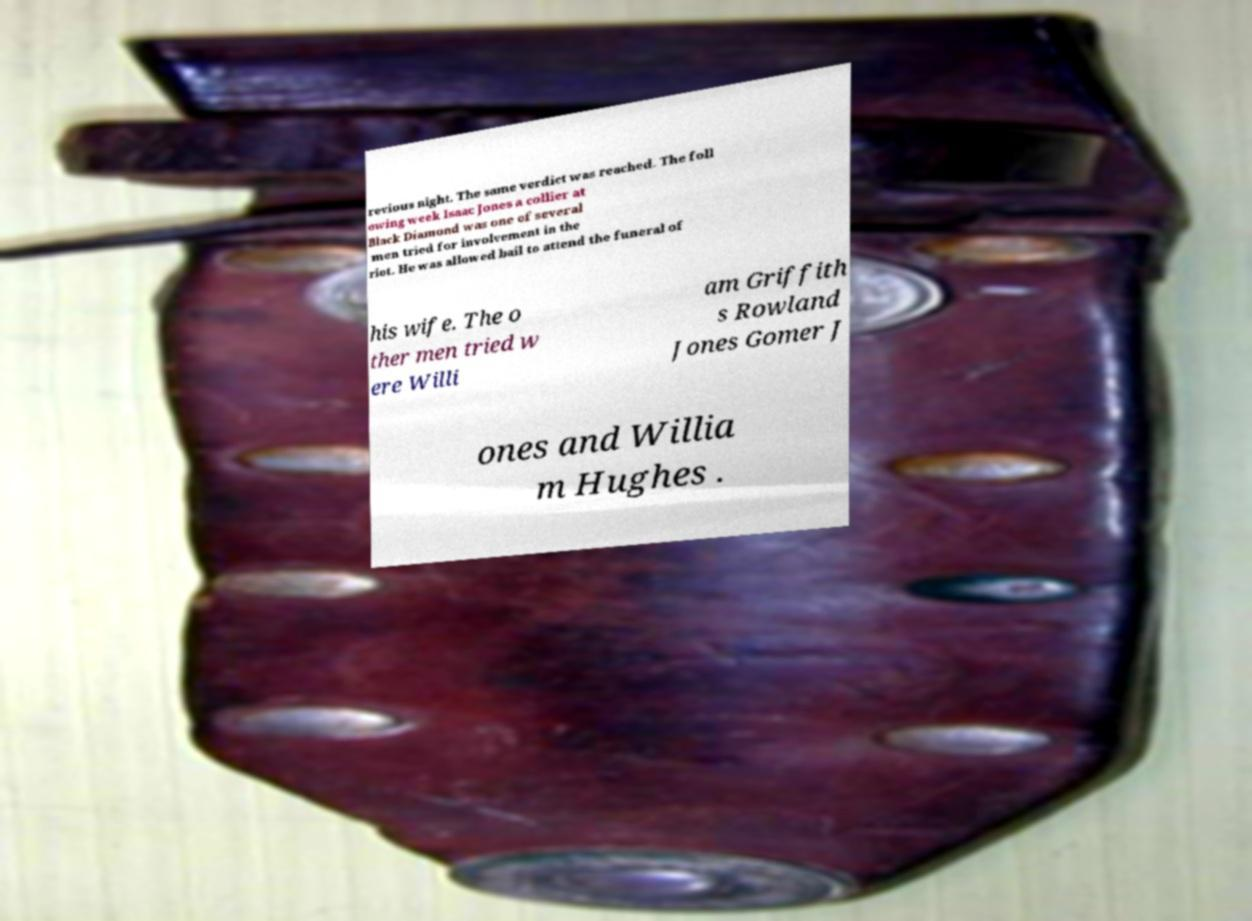There's text embedded in this image that I need extracted. Can you transcribe it verbatim? revious night. The same verdict was reached. The foll owing week Isaac Jones a collier at Black Diamond was one of several men tried for involvement in the riot. He was allowed bail to attend the funeral of his wife. The o ther men tried w ere Willi am Griffith s Rowland Jones Gomer J ones and Willia m Hughes . 